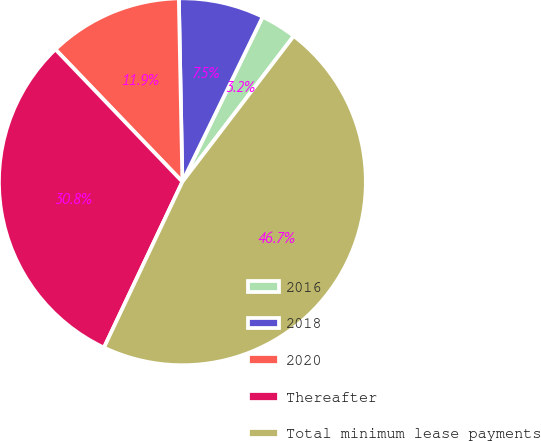Convert chart. <chart><loc_0><loc_0><loc_500><loc_500><pie_chart><fcel>2016<fcel>2018<fcel>2020<fcel>Thereafter<fcel>Total minimum lease payments<nl><fcel>3.17%<fcel>7.52%<fcel>11.86%<fcel>30.8%<fcel>46.65%<nl></chart> 